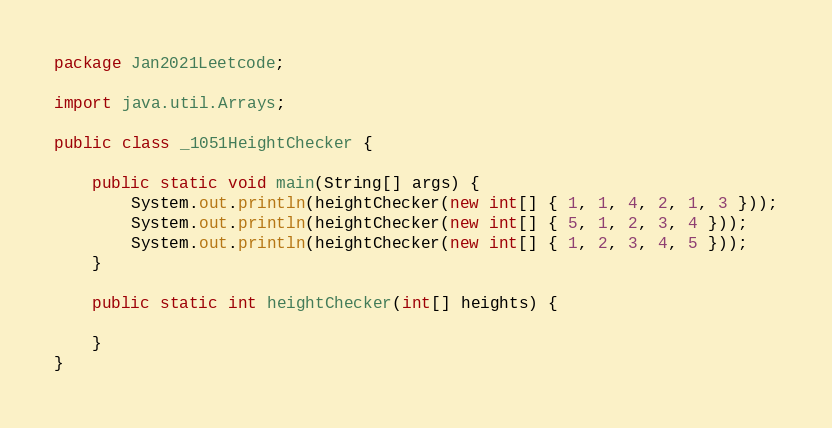Convert code to text. <code><loc_0><loc_0><loc_500><loc_500><_Java_>package Jan2021Leetcode;

import java.util.Arrays;

public class _1051HeightChecker {

	public static void main(String[] args) {
		System.out.println(heightChecker(new int[] { 1, 1, 4, 2, 1, 3 }));
		System.out.println(heightChecker(new int[] { 5, 1, 2, 3, 4 }));
		System.out.println(heightChecker(new int[] { 1, 2, 3, 4, 5 }));
	}

	public static int heightChecker(int[] heights) {

	}
}
</code> 